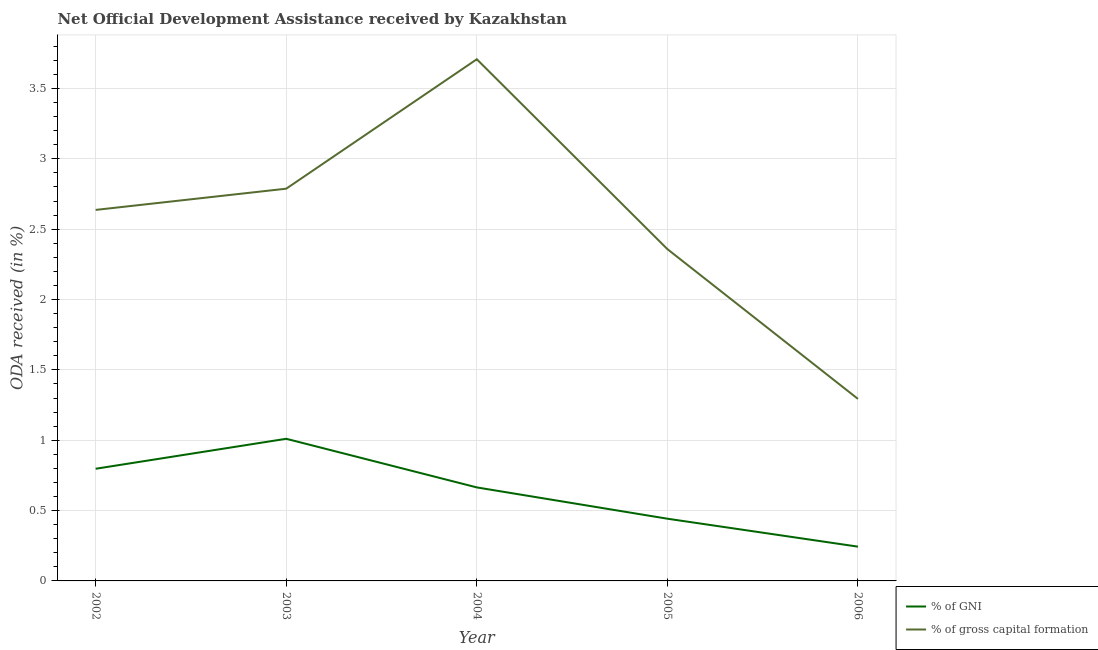How many different coloured lines are there?
Provide a short and direct response. 2. What is the oda received as percentage of gross capital formation in 2005?
Offer a very short reply. 2.36. Across all years, what is the maximum oda received as percentage of gross capital formation?
Offer a terse response. 3.71. Across all years, what is the minimum oda received as percentage of gross capital formation?
Your answer should be compact. 1.29. What is the total oda received as percentage of gni in the graph?
Ensure brevity in your answer.  3.16. What is the difference between the oda received as percentage of gni in 2004 and that in 2005?
Your response must be concise. 0.22. What is the difference between the oda received as percentage of gni in 2006 and the oda received as percentage of gross capital formation in 2002?
Your answer should be very brief. -2.39. What is the average oda received as percentage of gross capital formation per year?
Your answer should be compact. 2.56. In the year 2006, what is the difference between the oda received as percentage of gross capital formation and oda received as percentage of gni?
Your response must be concise. 1.05. In how many years, is the oda received as percentage of gni greater than 2.1 %?
Offer a terse response. 0. What is the ratio of the oda received as percentage of gni in 2004 to that in 2006?
Make the answer very short. 2.73. Is the oda received as percentage of gross capital formation in 2004 less than that in 2006?
Your answer should be compact. No. What is the difference between the highest and the second highest oda received as percentage of gni?
Your answer should be compact. 0.21. What is the difference between the highest and the lowest oda received as percentage of gross capital formation?
Ensure brevity in your answer.  2.41. Does the oda received as percentage of gni monotonically increase over the years?
Make the answer very short. No. What is the difference between two consecutive major ticks on the Y-axis?
Give a very brief answer. 0.5. Does the graph contain any zero values?
Your answer should be very brief. No. Does the graph contain grids?
Your answer should be very brief. Yes. How many legend labels are there?
Your answer should be compact. 2. What is the title of the graph?
Your response must be concise. Net Official Development Assistance received by Kazakhstan. What is the label or title of the Y-axis?
Ensure brevity in your answer.  ODA received (in %). What is the ODA received (in %) in % of GNI in 2002?
Make the answer very short. 0.8. What is the ODA received (in %) of % of gross capital formation in 2002?
Make the answer very short. 2.64. What is the ODA received (in %) in % of GNI in 2003?
Ensure brevity in your answer.  1.01. What is the ODA received (in %) of % of gross capital formation in 2003?
Provide a short and direct response. 2.79. What is the ODA received (in %) of % of GNI in 2004?
Offer a very short reply. 0.66. What is the ODA received (in %) of % of gross capital formation in 2004?
Give a very brief answer. 3.71. What is the ODA received (in %) in % of GNI in 2005?
Ensure brevity in your answer.  0.44. What is the ODA received (in %) in % of gross capital formation in 2005?
Offer a terse response. 2.36. What is the ODA received (in %) in % of GNI in 2006?
Give a very brief answer. 0.24. What is the ODA received (in %) of % of gross capital formation in 2006?
Your answer should be very brief. 1.29. Across all years, what is the maximum ODA received (in %) of % of GNI?
Offer a very short reply. 1.01. Across all years, what is the maximum ODA received (in %) in % of gross capital formation?
Keep it short and to the point. 3.71. Across all years, what is the minimum ODA received (in %) in % of GNI?
Your answer should be compact. 0.24. Across all years, what is the minimum ODA received (in %) in % of gross capital formation?
Offer a terse response. 1.29. What is the total ODA received (in %) of % of GNI in the graph?
Offer a very short reply. 3.16. What is the total ODA received (in %) of % of gross capital formation in the graph?
Provide a succinct answer. 12.78. What is the difference between the ODA received (in %) of % of GNI in 2002 and that in 2003?
Keep it short and to the point. -0.21. What is the difference between the ODA received (in %) in % of gross capital formation in 2002 and that in 2003?
Your response must be concise. -0.15. What is the difference between the ODA received (in %) in % of GNI in 2002 and that in 2004?
Provide a succinct answer. 0.13. What is the difference between the ODA received (in %) of % of gross capital formation in 2002 and that in 2004?
Your answer should be compact. -1.07. What is the difference between the ODA received (in %) in % of GNI in 2002 and that in 2005?
Offer a terse response. 0.35. What is the difference between the ODA received (in %) in % of gross capital formation in 2002 and that in 2005?
Provide a succinct answer. 0.28. What is the difference between the ODA received (in %) of % of GNI in 2002 and that in 2006?
Ensure brevity in your answer.  0.55. What is the difference between the ODA received (in %) of % of gross capital formation in 2002 and that in 2006?
Ensure brevity in your answer.  1.34. What is the difference between the ODA received (in %) of % of GNI in 2003 and that in 2004?
Your answer should be compact. 0.35. What is the difference between the ODA received (in %) in % of gross capital formation in 2003 and that in 2004?
Provide a succinct answer. -0.92. What is the difference between the ODA received (in %) of % of GNI in 2003 and that in 2005?
Offer a terse response. 0.57. What is the difference between the ODA received (in %) in % of gross capital formation in 2003 and that in 2005?
Offer a terse response. 0.43. What is the difference between the ODA received (in %) of % of GNI in 2003 and that in 2006?
Your answer should be very brief. 0.77. What is the difference between the ODA received (in %) in % of gross capital formation in 2003 and that in 2006?
Make the answer very short. 1.49. What is the difference between the ODA received (in %) in % of GNI in 2004 and that in 2005?
Provide a succinct answer. 0.22. What is the difference between the ODA received (in %) in % of gross capital formation in 2004 and that in 2005?
Give a very brief answer. 1.35. What is the difference between the ODA received (in %) of % of GNI in 2004 and that in 2006?
Provide a succinct answer. 0.42. What is the difference between the ODA received (in %) in % of gross capital formation in 2004 and that in 2006?
Provide a succinct answer. 2.41. What is the difference between the ODA received (in %) in % of GNI in 2005 and that in 2006?
Your answer should be compact. 0.2. What is the difference between the ODA received (in %) of % of gross capital formation in 2005 and that in 2006?
Provide a succinct answer. 1.06. What is the difference between the ODA received (in %) of % of GNI in 2002 and the ODA received (in %) of % of gross capital formation in 2003?
Ensure brevity in your answer.  -1.99. What is the difference between the ODA received (in %) in % of GNI in 2002 and the ODA received (in %) in % of gross capital formation in 2004?
Offer a terse response. -2.91. What is the difference between the ODA received (in %) of % of GNI in 2002 and the ODA received (in %) of % of gross capital formation in 2005?
Provide a short and direct response. -1.56. What is the difference between the ODA received (in %) in % of GNI in 2002 and the ODA received (in %) in % of gross capital formation in 2006?
Ensure brevity in your answer.  -0.5. What is the difference between the ODA received (in %) in % of GNI in 2003 and the ODA received (in %) in % of gross capital formation in 2004?
Ensure brevity in your answer.  -2.7. What is the difference between the ODA received (in %) of % of GNI in 2003 and the ODA received (in %) of % of gross capital formation in 2005?
Give a very brief answer. -1.35. What is the difference between the ODA received (in %) in % of GNI in 2003 and the ODA received (in %) in % of gross capital formation in 2006?
Provide a short and direct response. -0.28. What is the difference between the ODA received (in %) in % of GNI in 2004 and the ODA received (in %) in % of gross capital formation in 2005?
Offer a terse response. -1.69. What is the difference between the ODA received (in %) of % of GNI in 2004 and the ODA received (in %) of % of gross capital formation in 2006?
Provide a succinct answer. -0.63. What is the difference between the ODA received (in %) in % of GNI in 2005 and the ODA received (in %) in % of gross capital formation in 2006?
Offer a terse response. -0.85. What is the average ODA received (in %) of % of GNI per year?
Keep it short and to the point. 0.63. What is the average ODA received (in %) in % of gross capital formation per year?
Make the answer very short. 2.56. In the year 2002, what is the difference between the ODA received (in %) in % of GNI and ODA received (in %) in % of gross capital formation?
Give a very brief answer. -1.84. In the year 2003, what is the difference between the ODA received (in %) of % of GNI and ODA received (in %) of % of gross capital formation?
Offer a terse response. -1.78. In the year 2004, what is the difference between the ODA received (in %) in % of GNI and ODA received (in %) in % of gross capital formation?
Offer a very short reply. -3.04. In the year 2005, what is the difference between the ODA received (in %) in % of GNI and ODA received (in %) in % of gross capital formation?
Provide a short and direct response. -1.92. In the year 2006, what is the difference between the ODA received (in %) of % of GNI and ODA received (in %) of % of gross capital formation?
Provide a succinct answer. -1.05. What is the ratio of the ODA received (in %) of % of GNI in 2002 to that in 2003?
Keep it short and to the point. 0.79. What is the ratio of the ODA received (in %) in % of gross capital formation in 2002 to that in 2003?
Ensure brevity in your answer.  0.95. What is the ratio of the ODA received (in %) in % of GNI in 2002 to that in 2004?
Offer a very short reply. 1.2. What is the ratio of the ODA received (in %) of % of gross capital formation in 2002 to that in 2004?
Your response must be concise. 0.71. What is the ratio of the ODA received (in %) in % of GNI in 2002 to that in 2005?
Give a very brief answer. 1.8. What is the ratio of the ODA received (in %) in % of gross capital formation in 2002 to that in 2005?
Give a very brief answer. 1.12. What is the ratio of the ODA received (in %) in % of GNI in 2002 to that in 2006?
Keep it short and to the point. 3.27. What is the ratio of the ODA received (in %) of % of gross capital formation in 2002 to that in 2006?
Ensure brevity in your answer.  2.04. What is the ratio of the ODA received (in %) in % of GNI in 2003 to that in 2004?
Offer a very short reply. 1.52. What is the ratio of the ODA received (in %) in % of gross capital formation in 2003 to that in 2004?
Your answer should be very brief. 0.75. What is the ratio of the ODA received (in %) of % of GNI in 2003 to that in 2005?
Your answer should be very brief. 2.28. What is the ratio of the ODA received (in %) in % of gross capital formation in 2003 to that in 2005?
Your answer should be compact. 1.18. What is the ratio of the ODA received (in %) in % of GNI in 2003 to that in 2006?
Your answer should be compact. 4.15. What is the ratio of the ODA received (in %) of % of gross capital formation in 2003 to that in 2006?
Offer a terse response. 2.15. What is the ratio of the ODA received (in %) of % of GNI in 2004 to that in 2005?
Your response must be concise. 1.5. What is the ratio of the ODA received (in %) in % of gross capital formation in 2004 to that in 2005?
Your response must be concise. 1.57. What is the ratio of the ODA received (in %) in % of GNI in 2004 to that in 2006?
Offer a terse response. 2.73. What is the ratio of the ODA received (in %) in % of gross capital formation in 2004 to that in 2006?
Offer a very short reply. 2.87. What is the ratio of the ODA received (in %) in % of GNI in 2005 to that in 2006?
Ensure brevity in your answer.  1.82. What is the ratio of the ODA received (in %) in % of gross capital formation in 2005 to that in 2006?
Give a very brief answer. 1.82. What is the difference between the highest and the second highest ODA received (in %) in % of GNI?
Give a very brief answer. 0.21. What is the difference between the highest and the second highest ODA received (in %) in % of gross capital formation?
Your response must be concise. 0.92. What is the difference between the highest and the lowest ODA received (in %) in % of GNI?
Provide a succinct answer. 0.77. What is the difference between the highest and the lowest ODA received (in %) in % of gross capital formation?
Provide a short and direct response. 2.41. 